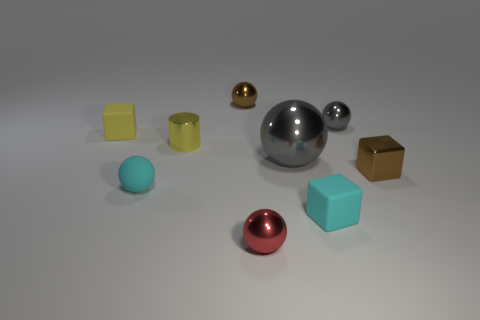Can you tell me about the different materials and textures present in this image? Certainly! The image showcases various objects with distinct materials and finishes. The large sphere in the center has a chrome finish reflecting the environment, suggesting a metallic material. The small yellow and blue blocks appear to have a matte surface, possibly made of plastic or painted wood. The brown cube on the right looks like it has a reflective metal surface, while the small red sphere has a slightly less reflective, possibly anodized metal finish. Each object presents a unique interaction with light and texture that hint at their material properties. 